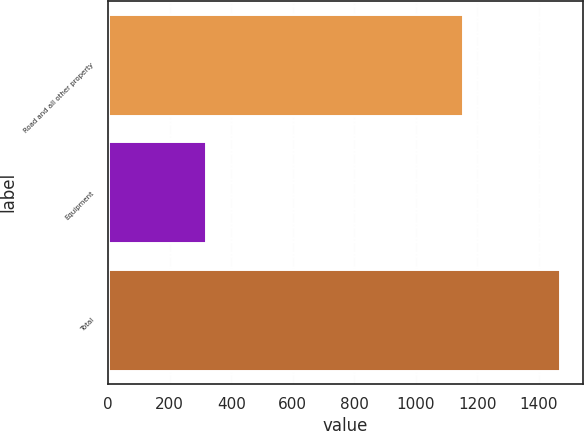Convert chart to OTSL. <chart><loc_0><loc_0><loc_500><loc_500><bar_chart><fcel>Road and all other property<fcel>Equipment<fcel>Total<nl><fcel>1153<fcel>317<fcel>1470<nl></chart> 